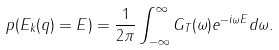Convert formula to latex. <formula><loc_0><loc_0><loc_500><loc_500>p ( E _ { k } ( q ) = E ) = \frac { 1 } { 2 \pi } \int _ { - \infty } ^ { \infty } G _ { T } ( \omega ) e ^ { - i \omega E } d \omega .</formula> 